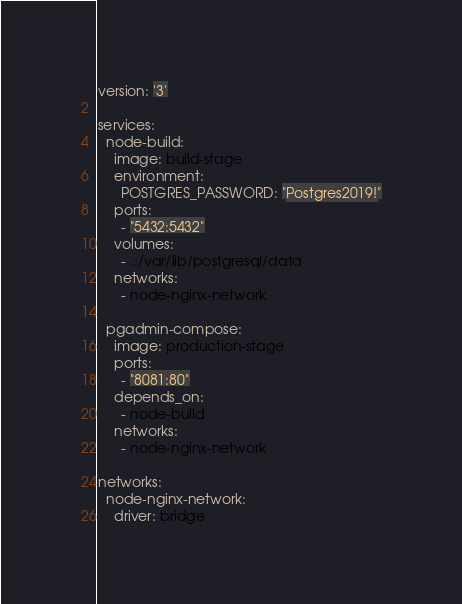Convert code to text. <code><loc_0><loc_0><loc_500><loc_500><_YAML_>version: '3'

services:
  node-build:
    image: build-stage
    environment:
      POSTGRES_PASSWORD: "Postgres2019!"
    ports:
      - "5432:5432"
    volumes:
      - .:/var/lib/postgresql/data 
    networks:
      - node-nginx-network
      
  pgadmin-compose:
    image: production-stage
    ports:
      - "8081:80"
    depends_on:
      - node-build
    networks:
      - node-nginx-network

networks: 
  node-nginx-network:
    driver: bridge
</code> 